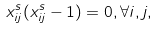Convert formula to latex. <formula><loc_0><loc_0><loc_500><loc_500>x ^ { s } _ { i j } ( x ^ { s } _ { i j } - 1 ) = 0 , \forall i , j ,</formula> 